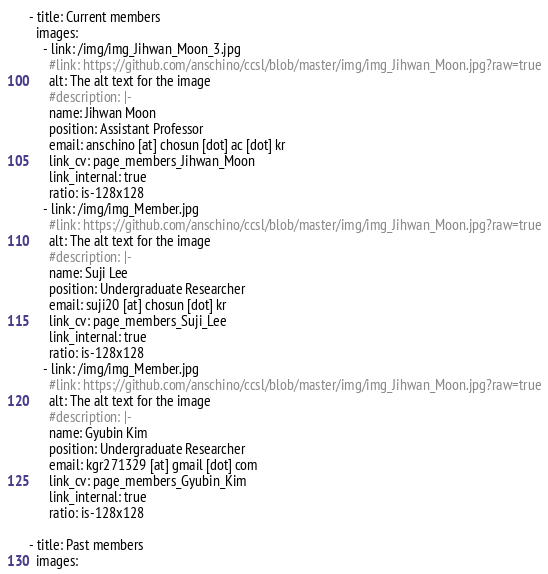<code> <loc_0><loc_0><loc_500><loc_500><_YAML_>- title: Current members
  images:
    - link: /img/img_Jihwan_Moon_3.jpg
      #link: https://github.com/anschino/ccsl/blob/master/img/img_Jihwan_Moon.jpg?raw=true
      alt: The alt text for the image
      #description: |-
      name: Jihwan Moon
      position: Assistant Professor
      email: anschino [at] chosun [dot] ac [dot] kr
      link_cv: page_members_Jihwan_Moon
      link_internal: true
      ratio: is-128x128
    - link: /img/img_Member.jpg
      #link: https://github.com/anschino/ccsl/blob/master/img/img_Jihwan_Moon.jpg?raw=true
      alt: The alt text for the image
      #description: |-
      name: Suji Lee
      position: Undergraduate Researcher
      email: suji20 [at] chosun [dot] kr
      link_cv: page_members_Suji_Lee
      link_internal: true
      ratio: is-128x128
    - link: /img/img_Member.jpg
      #link: https://github.com/anschino/ccsl/blob/master/img/img_Jihwan_Moon.jpg?raw=true
      alt: The alt text for the image
      #description: |-
      name: Gyubin Kim
      position: Undergraduate Researcher
      email: kgr271329 [at] gmail [dot] com
      link_cv: page_members_Gyubin_Kim
      link_internal: true
      ratio: is-128x128

- title: Past members
  images:</code> 